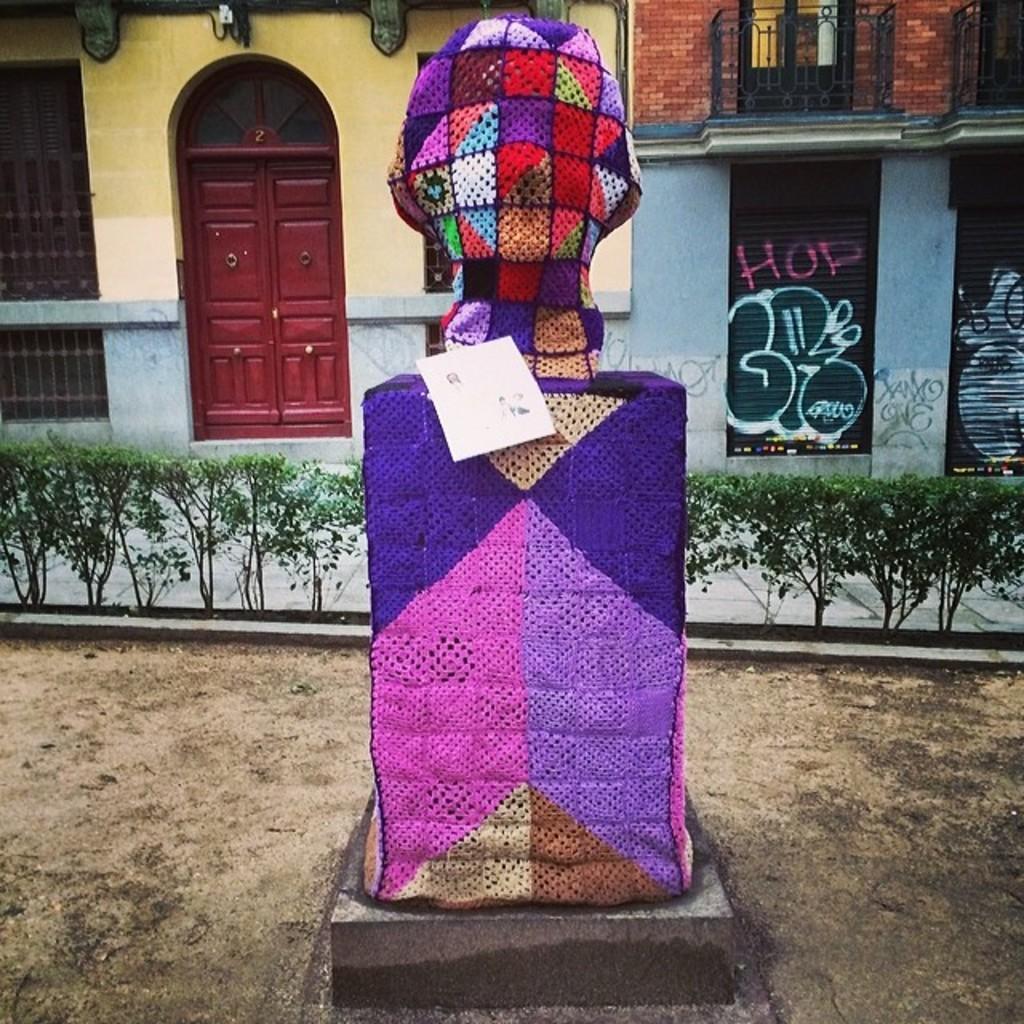In one or two sentences, can you explain what this image depicts? In this picture we can see the art, beside that we can see the plants. In the background we can see the buildings. On the left there is a door and gate. On the right there are two shelters. 